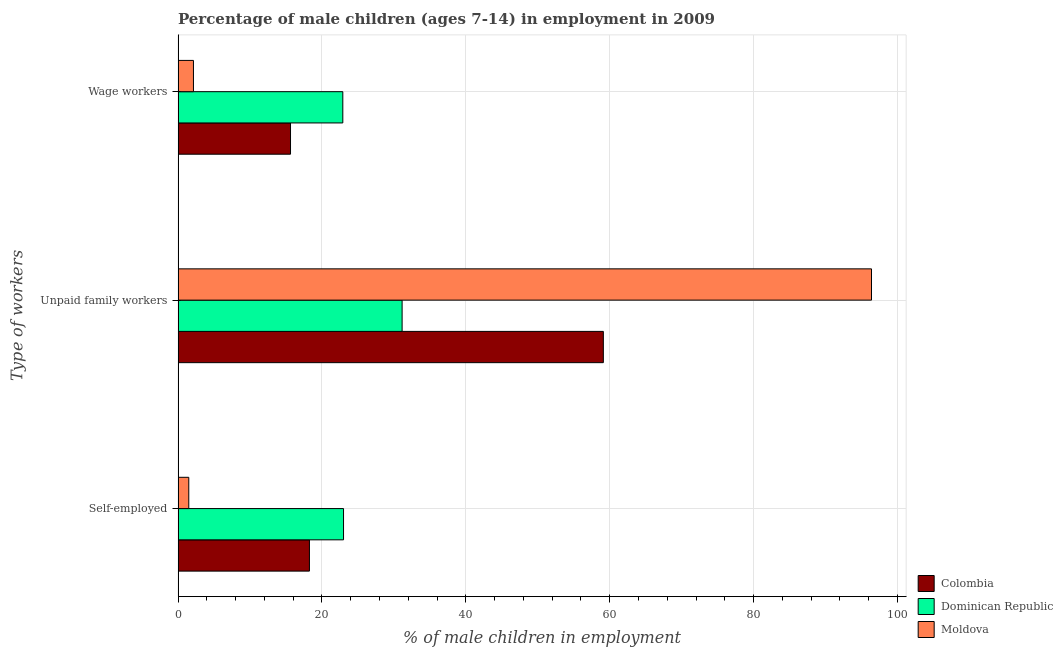Are the number of bars per tick equal to the number of legend labels?
Keep it short and to the point. Yes. Are the number of bars on each tick of the Y-axis equal?
Keep it short and to the point. Yes. How many bars are there on the 1st tick from the top?
Your response must be concise. 3. How many bars are there on the 2nd tick from the bottom?
Make the answer very short. 3. What is the label of the 2nd group of bars from the top?
Make the answer very short. Unpaid family workers. What is the percentage of children employed as wage workers in Dominican Republic?
Provide a succinct answer. 22.9. Across all countries, what is the maximum percentage of children employed as unpaid family workers?
Your answer should be very brief. 96.38. Across all countries, what is the minimum percentage of children employed as unpaid family workers?
Your response must be concise. 31.14. In which country was the percentage of self employed children maximum?
Offer a very short reply. Dominican Republic. In which country was the percentage of self employed children minimum?
Offer a very short reply. Moldova. What is the total percentage of children employed as wage workers in the graph?
Offer a terse response. 40.67. What is the difference between the percentage of children employed as wage workers in Moldova and that in Dominican Republic?
Provide a succinct answer. -20.76. What is the difference between the percentage of children employed as wage workers in Moldova and the percentage of children employed as unpaid family workers in Colombia?
Your response must be concise. -56.97. What is the average percentage of children employed as wage workers per country?
Your response must be concise. 13.56. What is the difference between the percentage of children employed as unpaid family workers and percentage of children employed as wage workers in Dominican Republic?
Provide a succinct answer. 8.24. What is the ratio of the percentage of self employed children in Dominican Republic to that in Moldova?
Make the answer very short. 15.44. What is the difference between the highest and the second highest percentage of self employed children?
Your answer should be very brief. 4.74. What is the difference between the highest and the lowest percentage of children employed as wage workers?
Your answer should be very brief. 20.76. Is the sum of the percentage of self employed children in Colombia and Moldova greater than the maximum percentage of children employed as unpaid family workers across all countries?
Your answer should be very brief. No. What does the 2nd bar from the top in Wage workers represents?
Give a very brief answer. Dominican Republic. What does the 1st bar from the bottom in Self-employed represents?
Ensure brevity in your answer.  Colombia. Is it the case that in every country, the sum of the percentage of self employed children and percentage of children employed as unpaid family workers is greater than the percentage of children employed as wage workers?
Ensure brevity in your answer.  Yes. Are all the bars in the graph horizontal?
Keep it short and to the point. Yes. How many countries are there in the graph?
Keep it short and to the point. 3. What is the difference between two consecutive major ticks on the X-axis?
Offer a terse response. 20. Are the values on the major ticks of X-axis written in scientific E-notation?
Offer a very short reply. No. Does the graph contain grids?
Offer a terse response. Yes. Where does the legend appear in the graph?
Your answer should be compact. Bottom right. How many legend labels are there?
Keep it short and to the point. 3. What is the title of the graph?
Make the answer very short. Percentage of male children (ages 7-14) in employment in 2009. Does "Malaysia" appear as one of the legend labels in the graph?
Keep it short and to the point. No. What is the label or title of the X-axis?
Provide a short and direct response. % of male children in employment. What is the label or title of the Y-axis?
Give a very brief answer. Type of workers. What is the % of male children in employment of Colombia in Self-employed?
Offer a terse response. 18.26. What is the % of male children in employment of Dominican Republic in Self-employed?
Provide a short and direct response. 23. What is the % of male children in employment in Moldova in Self-employed?
Keep it short and to the point. 1.49. What is the % of male children in employment in Colombia in Unpaid family workers?
Keep it short and to the point. 59.11. What is the % of male children in employment of Dominican Republic in Unpaid family workers?
Provide a succinct answer. 31.14. What is the % of male children in employment in Moldova in Unpaid family workers?
Provide a succinct answer. 96.38. What is the % of male children in employment in Colombia in Wage workers?
Your answer should be very brief. 15.63. What is the % of male children in employment of Dominican Republic in Wage workers?
Keep it short and to the point. 22.9. What is the % of male children in employment of Moldova in Wage workers?
Offer a very short reply. 2.14. Across all Type of workers, what is the maximum % of male children in employment of Colombia?
Your response must be concise. 59.11. Across all Type of workers, what is the maximum % of male children in employment in Dominican Republic?
Keep it short and to the point. 31.14. Across all Type of workers, what is the maximum % of male children in employment in Moldova?
Offer a very short reply. 96.38. Across all Type of workers, what is the minimum % of male children in employment of Colombia?
Offer a terse response. 15.63. Across all Type of workers, what is the minimum % of male children in employment of Dominican Republic?
Provide a short and direct response. 22.9. Across all Type of workers, what is the minimum % of male children in employment of Moldova?
Keep it short and to the point. 1.49. What is the total % of male children in employment in Colombia in the graph?
Your answer should be compact. 93. What is the total % of male children in employment of Dominican Republic in the graph?
Offer a terse response. 77.04. What is the total % of male children in employment of Moldova in the graph?
Your answer should be very brief. 100.01. What is the difference between the % of male children in employment in Colombia in Self-employed and that in Unpaid family workers?
Offer a very short reply. -40.85. What is the difference between the % of male children in employment in Dominican Republic in Self-employed and that in Unpaid family workers?
Offer a terse response. -8.14. What is the difference between the % of male children in employment in Moldova in Self-employed and that in Unpaid family workers?
Your answer should be very brief. -94.89. What is the difference between the % of male children in employment in Colombia in Self-employed and that in Wage workers?
Offer a very short reply. 2.63. What is the difference between the % of male children in employment of Moldova in Self-employed and that in Wage workers?
Your answer should be very brief. -0.65. What is the difference between the % of male children in employment in Colombia in Unpaid family workers and that in Wage workers?
Your answer should be compact. 43.48. What is the difference between the % of male children in employment in Dominican Republic in Unpaid family workers and that in Wage workers?
Offer a terse response. 8.24. What is the difference between the % of male children in employment of Moldova in Unpaid family workers and that in Wage workers?
Keep it short and to the point. 94.24. What is the difference between the % of male children in employment in Colombia in Self-employed and the % of male children in employment in Dominican Republic in Unpaid family workers?
Offer a terse response. -12.88. What is the difference between the % of male children in employment in Colombia in Self-employed and the % of male children in employment in Moldova in Unpaid family workers?
Provide a succinct answer. -78.12. What is the difference between the % of male children in employment of Dominican Republic in Self-employed and the % of male children in employment of Moldova in Unpaid family workers?
Offer a terse response. -73.38. What is the difference between the % of male children in employment in Colombia in Self-employed and the % of male children in employment in Dominican Republic in Wage workers?
Offer a very short reply. -4.64. What is the difference between the % of male children in employment of Colombia in Self-employed and the % of male children in employment of Moldova in Wage workers?
Your answer should be compact. 16.12. What is the difference between the % of male children in employment of Dominican Republic in Self-employed and the % of male children in employment of Moldova in Wage workers?
Ensure brevity in your answer.  20.86. What is the difference between the % of male children in employment in Colombia in Unpaid family workers and the % of male children in employment in Dominican Republic in Wage workers?
Keep it short and to the point. 36.21. What is the difference between the % of male children in employment of Colombia in Unpaid family workers and the % of male children in employment of Moldova in Wage workers?
Provide a succinct answer. 56.97. What is the average % of male children in employment of Dominican Republic per Type of workers?
Your answer should be compact. 25.68. What is the average % of male children in employment of Moldova per Type of workers?
Give a very brief answer. 33.34. What is the difference between the % of male children in employment in Colombia and % of male children in employment in Dominican Republic in Self-employed?
Your answer should be very brief. -4.74. What is the difference between the % of male children in employment in Colombia and % of male children in employment in Moldova in Self-employed?
Your response must be concise. 16.77. What is the difference between the % of male children in employment in Dominican Republic and % of male children in employment in Moldova in Self-employed?
Keep it short and to the point. 21.51. What is the difference between the % of male children in employment of Colombia and % of male children in employment of Dominican Republic in Unpaid family workers?
Offer a terse response. 27.97. What is the difference between the % of male children in employment in Colombia and % of male children in employment in Moldova in Unpaid family workers?
Provide a short and direct response. -37.27. What is the difference between the % of male children in employment of Dominican Republic and % of male children in employment of Moldova in Unpaid family workers?
Your response must be concise. -65.24. What is the difference between the % of male children in employment in Colombia and % of male children in employment in Dominican Republic in Wage workers?
Your response must be concise. -7.27. What is the difference between the % of male children in employment of Colombia and % of male children in employment of Moldova in Wage workers?
Offer a very short reply. 13.49. What is the difference between the % of male children in employment in Dominican Republic and % of male children in employment in Moldova in Wage workers?
Your response must be concise. 20.76. What is the ratio of the % of male children in employment in Colombia in Self-employed to that in Unpaid family workers?
Provide a succinct answer. 0.31. What is the ratio of the % of male children in employment in Dominican Republic in Self-employed to that in Unpaid family workers?
Your answer should be very brief. 0.74. What is the ratio of the % of male children in employment in Moldova in Self-employed to that in Unpaid family workers?
Keep it short and to the point. 0.02. What is the ratio of the % of male children in employment in Colombia in Self-employed to that in Wage workers?
Offer a terse response. 1.17. What is the ratio of the % of male children in employment in Dominican Republic in Self-employed to that in Wage workers?
Offer a very short reply. 1. What is the ratio of the % of male children in employment of Moldova in Self-employed to that in Wage workers?
Provide a succinct answer. 0.7. What is the ratio of the % of male children in employment of Colombia in Unpaid family workers to that in Wage workers?
Give a very brief answer. 3.78. What is the ratio of the % of male children in employment in Dominican Republic in Unpaid family workers to that in Wage workers?
Ensure brevity in your answer.  1.36. What is the ratio of the % of male children in employment of Moldova in Unpaid family workers to that in Wage workers?
Ensure brevity in your answer.  45.04. What is the difference between the highest and the second highest % of male children in employment in Colombia?
Offer a very short reply. 40.85. What is the difference between the highest and the second highest % of male children in employment in Dominican Republic?
Ensure brevity in your answer.  8.14. What is the difference between the highest and the second highest % of male children in employment of Moldova?
Provide a short and direct response. 94.24. What is the difference between the highest and the lowest % of male children in employment of Colombia?
Your response must be concise. 43.48. What is the difference between the highest and the lowest % of male children in employment of Dominican Republic?
Keep it short and to the point. 8.24. What is the difference between the highest and the lowest % of male children in employment of Moldova?
Offer a terse response. 94.89. 